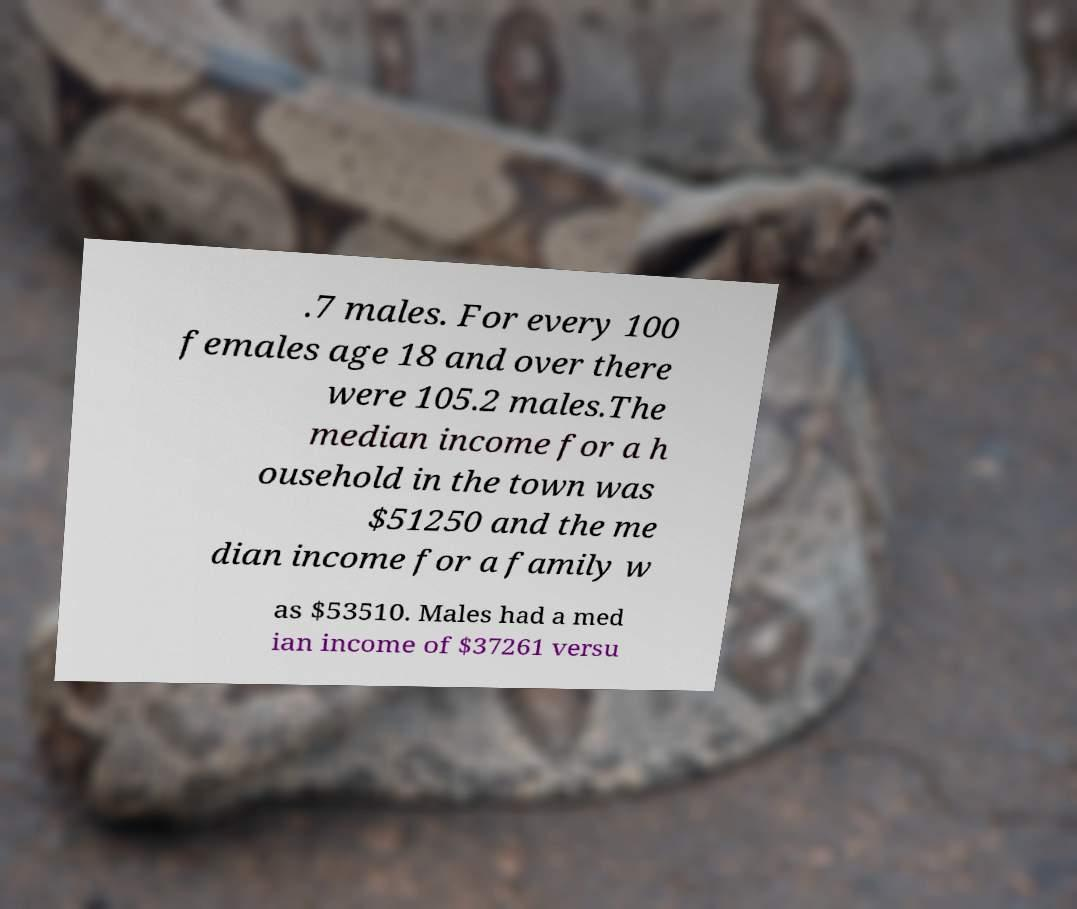Please read and relay the text visible in this image. What does it say? .7 males. For every 100 females age 18 and over there were 105.2 males.The median income for a h ousehold in the town was $51250 and the me dian income for a family w as $53510. Males had a med ian income of $37261 versu 